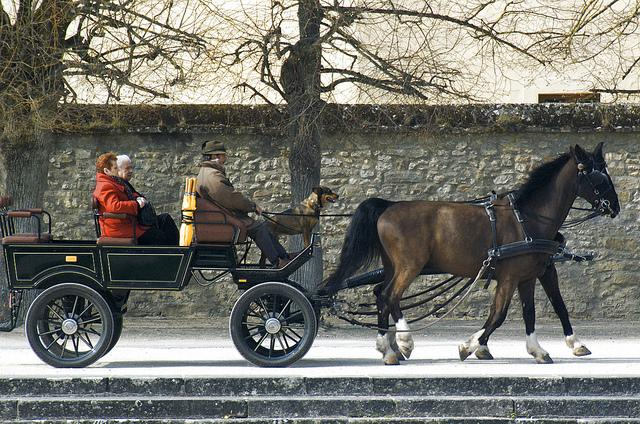In which season are the people traveling on the black horse drawn coach? winter 